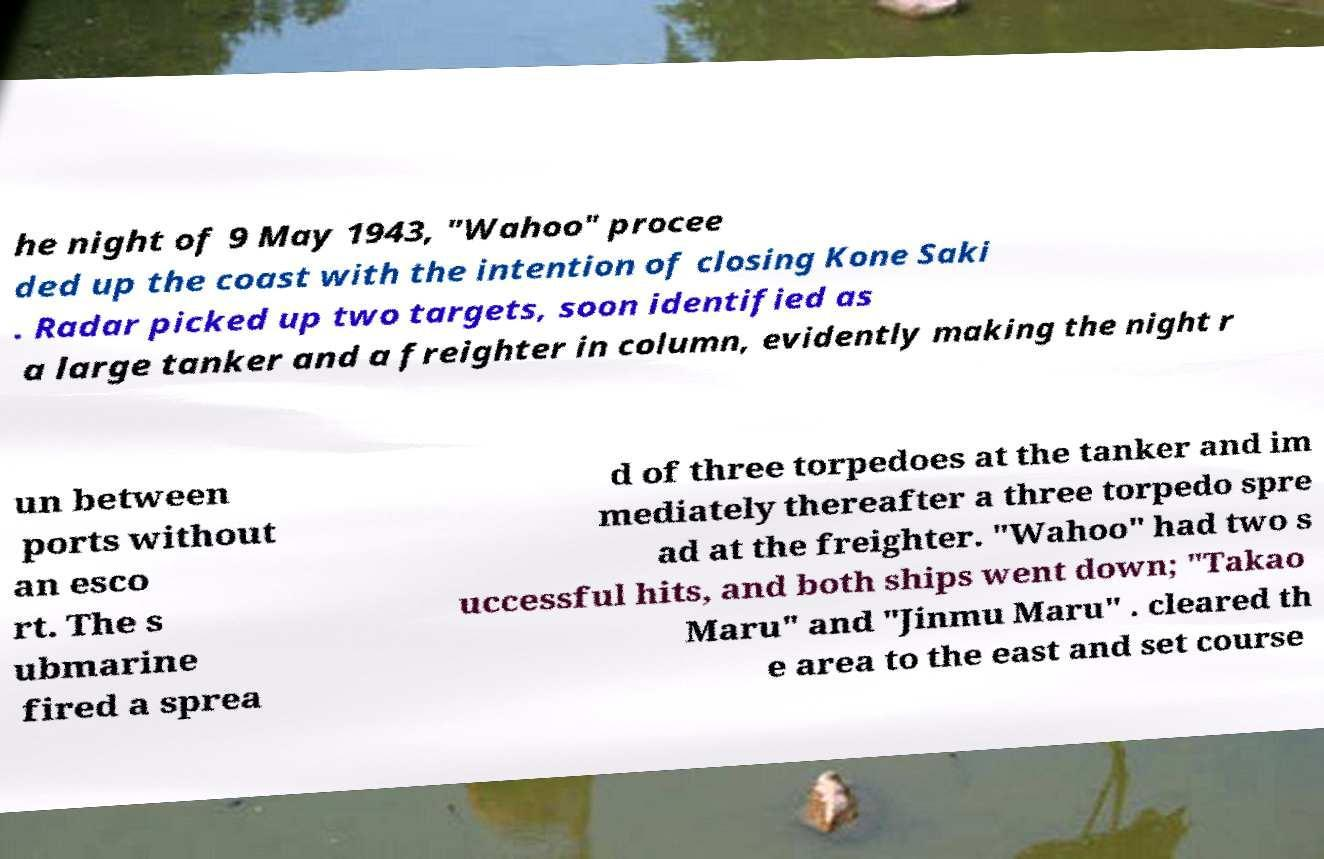Please identify and transcribe the text found in this image. he night of 9 May 1943, "Wahoo" procee ded up the coast with the intention of closing Kone Saki . Radar picked up two targets, soon identified as a large tanker and a freighter in column, evidently making the night r un between ports without an esco rt. The s ubmarine fired a sprea d of three torpedoes at the tanker and im mediately thereafter a three torpedo spre ad at the freighter. "Wahoo" had two s uccessful hits, and both ships went down; "Takao Maru" and "Jinmu Maru" . cleared th e area to the east and set course 